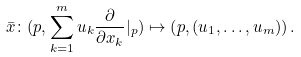<formula> <loc_0><loc_0><loc_500><loc_500>\bar { x } \colon ( p , \sum _ { k = 1 } ^ { m } u _ { k } \frac { \partial } { \partial x _ { k } } | _ { p } ) \mapsto \left ( p , ( u _ { 1 } , \dots , u _ { m } ) \right ) .</formula> 